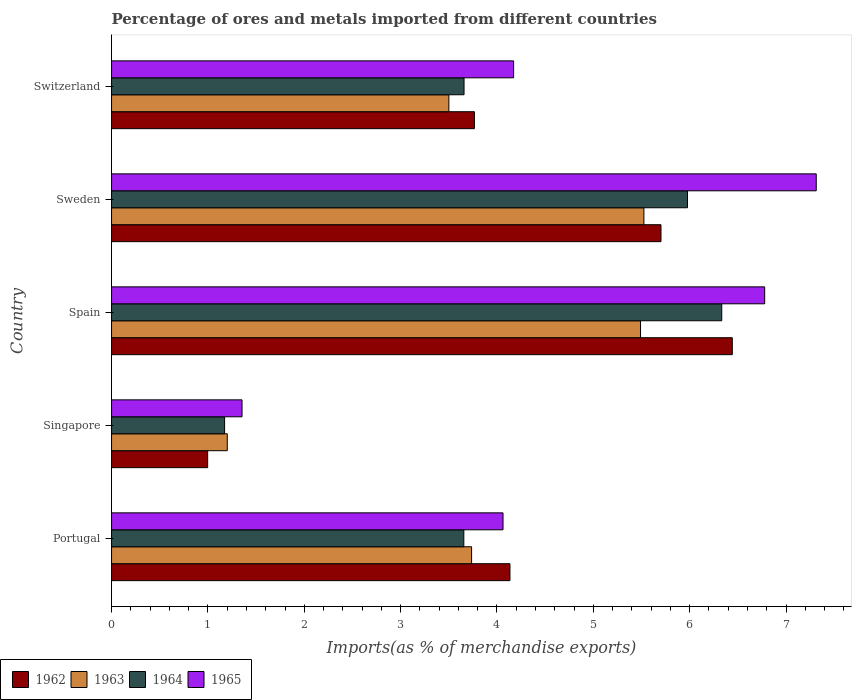How many different coloured bars are there?
Offer a very short reply. 4. How many groups of bars are there?
Your answer should be very brief. 5. How many bars are there on the 1st tick from the bottom?
Provide a short and direct response. 4. What is the label of the 1st group of bars from the top?
Keep it short and to the point. Switzerland. What is the percentage of imports to different countries in 1962 in Portugal?
Your answer should be very brief. 4.13. Across all countries, what is the maximum percentage of imports to different countries in 1965?
Your answer should be very brief. 7.31. Across all countries, what is the minimum percentage of imports to different countries in 1963?
Provide a succinct answer. 1.2. In which country was the percentage of imports to different countries in 1965 maximum?
Provide a succinct answer. Sweden. In which country was the percentage of imports to different countries in 1962 minimum?
Provide a succinct answer. Singapore. What is the total percentage of imports to different countries in 1965 in the graph?
Offer a very short reply. 23.68. What is the difference between the percentage of imports to different countries in 1963 in Portugal and that in Spain?
Give a very brief answer. -1.75. What is the difference between the percentage of imports to different countries in 1965 in Sweden and the percentage of imports to different countries in 1963 in Spain?
Give a very brief answer. 1.82. What is the average percentage of imports to different countries in 1963 per country?
Your response must be concise. 3.89. What is the difference between the percentage of imports to different countries in 1965 and percentage of imports to different countries in 1964 in Sweden?
Provide a short and direct response. 1.34. In how many countries, is the percentage of imports to different countries in 1962 greater than 6.8 %?
Your answer should be very brief. 0. What is the ratio of the percentage of imports to different countries in 1963 in Spain to that in Switzerland?
Give a very brief answer. 1.57. Is the difference between the percentage of imports to different countries in 1965 in Portugal and Switzerland greater than the difference between the percentage of imports to different countries in 1964 in Portugal and Switzerland?
Your response must be concise. No. What is the difference between the highest and the second highest percentage of imports to different countries in 1964?
Your answer should be compact. 0.36. What is the difference between the highest and the lowest percentage of imports to different countries in 1962?
Your answer should be very brief. 5.45. What does the 2nd bar from the top in Switzerland represents?
Your answer should be compact. 1964. What does the 2nd bar from the bottom in Portugal represents?
Provide a succinct answer. 1963. Are all the bars in the graph horizontal?
Your answer should be very brief. Yes. Does the graph contain grids?
Ensure brevity in your answer.  No. How many legend labels are there?
Provide a succinct answer. 4. What is the title of the graph?
Your answer should be compact. Percentage of ores and metals imported from different countries. Does "1981" appear as one of the legend labels in the graph?
Offer a very short reply. No. What is the label or title of the X-axis?
Ensure brevity in your answer.  Imports(as % of merchandise exports). What is the label or title of the Y-axis?
Keep it short and to the point. Country. What is the Imports(as % of merchandise exports) in 1962 in Portugal?
Provide a succinct answer. 4.13. What is the Imports(as % of merchandise exports) of 1963 in Portugal?
Offer a very short reply. 3.74. What is the Imports(as % of merchandise exports) of 1964 in Portugal?
Offer a terse response. 3.66. What is the Imports(as % of merchandise exports) in 1965 in Portugal?
Your response must be concise. 4.06. What is the Imports(as % of merchandise exports) in 1962 in Singapore?
Offer a very short reply. 1. What is the Imports(as % of merchandise exports) in 1963 in Singapore?
Keep it short and to the point. 1.2. What is the Imports(as % of merchandise exports) in 1964 in Singapore?
Your answer should be compact. 1.17. What is the Imports(as % of merchandise exports) of 1965 in Singapore?
Provide a succinct answer. 1.35. What is the Imports(as % of merchandise exports) of 1962 in Spain?
Give a very brief answer. 6.44. What is the Imports(as % of merchandise exports) of 1963 in Spain?
Make the answer very short. 5.49. What is the Imports(as % of merchandise exports) in 1964 in Spain?
Make the answer very short. 6.33. What is the Imports(as % of merchandise exports) in 1965 in Spain?
Offer a very short reply. 6.78. What is the Imports(as % of merchandise exports) in 1962 in Sweden?
Your response must be concise. 5.7. What is the Imports(as % of merchandise exports) in 1963 in Sweden?
Provide a succinct answer. 5.52. What is the Imports(as % of merchandise exports) of 1964 in Sweden?
Provide a succinct answer. 5.98. What is the Imports(as % of merchandise exports) of 1965 in Sweden?
Your answer should be compact. 7.31. What is the Imports(as % of merchandise exports) in 1962 in Switzerland?
Offer a terse response. 3.77. What is the Imports(as % of merchandise exports) in 1963 in Switzerland?
Provide a short and direct response. 3.5. What is the Imports(as % of merchandise exports) in 1964 in Switzerland?
Give a very brief answer. 3.66. What is the Imports(as % of merchandise exports) in 1965 in Switzerland?
Your answer should be compact. 4.17. Across all countries, what is the maximum Imports(as % of merchandise exports) of 1962?
Keep it short and to the point. 6.44. Across all countries, what is the maximum Imports(as % of merchandise exports) of 1963?
Ensure brevity in your answer.  5.52. Across all countries, what is the maximum Imports(as % of merchandise exports) of 1964?
Your response must be concise. 6.33. Across all countries, what is the maximum Imports(as % of merchandise exports) in 1965?
Provide a short and direct response. 7.31. Across all countries, what is the minimum Imports(as % of merchandise exports) in 1962?
Your answer should be compact. 1. Across all countries, what is the minimum Imports(as % of merchandise exports) in 1963?
Offer a terse response. 1.2. Across all countries, what is the minimum Imports(as % of merchandise exports) in 1964?
Your response must be concise. 1.17. Across all countries, what is the minimum Imports(as % of merchandise exports) of 1965?
Offer a very short reply. 1.35. What is the total Imports(as % of merchandise exports) in 1962 in the graph?
Make the answer very short. 21.04. What is the total Imports(as % of merchandise exports) in 1963 in the graph?
Offer a terse response. 19.45. What is the total Imports(as % of merchandise exports) in 1964 in the graph?
Provide a succinct answer. 20.8. What is the total Imports(as % of merchandise exports) of 1965 in the graph?
Make the answer very short. 23.68. What is the difference between the Imports(as % of merchandise exports) in 1962 in Portugal and that in Singapore?
Your answer should be very brief. 3.14. What is the difference between the Imports(as % of merchandise exports) in 1963 in Portugal and that in Singapore?
Give a very brief answer. 2.54. What is the difference between the Imports(as % of merchandise exports) in 1964 in Portugal and that in Singapore?
Your answer should be very brief. 2.48. What is the difference between the Imports(as % of merchandise exports) in 1965 in Portugal and that in Singapore?
Your answer should be compact. 2.71. What is the difference between the Imports(as % of merchandise exports) in 1962 in Portugal and that in Spain?
Provide a short and direct response. -2.31. What is the difference between the Imports(as % of merchandise exports) of 1963 in Portugal and that in Spain?
Offer a very short reply. -1.75. What is the difference between the Imports(as % of merchandise exports) in 1964 in Portugal and that in Spain?
Keep it short and to the point. -2.68. What is the difference between the Imports(as % of merchandise exports) of 1965 in Portugal and that in Spain?
Make the answer very short. -2.72. What is the difference between the Imports(as % of merchandise exports) in 1962 in Portugal and that in Sweden?
Your answer should be compact. -1.57. What is the difference between the Imports(as % of merchandise exports) in 1963 in Portugal and that in Sweden?
Keep it short and to the point. -1.79. What is the difference between the Imports(as % of merchandise exports) of 1964 in Portugal and that in Sweden?
Your answer should be very brief. -2.32. What is the difference between the Imports(as % of merchandise exports) of 1965 in Portugal and that in Sweden?
Offer a very short reply. -3.25. What is the difference between the Imports(as % of merchandise exports) in 1962 in Portugal and that in Switzerland?
Provide a short and direct response. 0.37. What is the difference between the Imports(as % of merchandise exports) of 1963 in Portugal and that in Switzerland?
Offer a very short reply. 0.24. What is the difference between the Imports(as % of merchandise exports) in 1964 in Portugal and that in Switzerland?
Provide a short and direct response. -0. What is the difference between the Imports(as % of merchandise exports) in 1965 in Portugal and that in Switzerland?
Your response must be concise. -0.11. What is the difference between the Imports(as % of merchandise exports) of 1962 in Singapore and that in Spain?
Give a very brief answer. -5.45. What is the difference between the Imports(as % of merchandise exports) of 1963 in Singapore and that in Spain?
Provide a succinct answer. -4.29. What is the difference between the Imports(as % of merchandise exports) in 1964 in Singapore and that in Spain?
Offer a very short reply. -5.16. What is the difference between the Imports(as % of merchandise exports) in 1965 in Singapore and that in Spain?
Ensure brevity in your answer.  -5.42. What is the difference between the Imports(as % of merchandise exports) of 1962 in Singapore and that in Sweden?
Your answer should be very brief. -4.7. What is the difference between the Imports(as % of merchandise exports) of 1963 in Singapore and that in Sweden?
Your response must be concise. -4.32. What is the difference between the Imports(as % of merchandise exports) in 1964 in Singapore and that in Sweden?
Provide a succinct answer. -4.8. What is the difference between the Imports(as % of merchandise exports) of 1965 in Singapore and that in Sweden?
Offer a terse response. -5.96. What is the difference between the Imports(as % of merchandise exports) of 1962 in Singapore and that in Switzerland?
Make the answer very short. -2.77. What is the difference between the Imports(as % of merchandise exports) of 1963 in Singapore and that in Switzerland?
Your answer should be very brief. -2.3. What is the difference between the Imports(as % of merchandise exports) in 1964 in Singapore and that in Switzerland?
Keep it short and to the point. -2.49. What is the difference between the Imports(as % of merchandise exports) in 1965 in Singapore and that in Switzerland?
Keep it short and to the point. -2.82. What is the difference between the Imports(as % of merchandise exports) of 1962 in Spain and that in Sweden?
Give a very brief answer. 0.74. What is the difference between the Imports(as % of merchandise exports) in 1963 in Spain and that in Sweden?
Offer a terse response. -0.04. What is the difference between the Imports(as % of merchandise exports) in 1964 in Spain and that in Sweden?
Give a very brief answer. 0.36. What is the difference between the Imports(as % of merchandise exports) of 1965 in Spain and that in Sweden?
Your answer should be compact. -0.54. What is the difference between the Imports(as % of merchandise exports) of 1962 in Spain and that in Switzerland?
Provide a succinct answer. 2.68. What is the difference between the Imports(as % of merchandise exports) in 1963 in Spain and that in Switzerland?
Provide a short and direct response. 1.99. What is the difference between the Imports(as % of merchandise exports) of 1964 in Spain and that in Switzerland?
Provide a short and direct response. 2.67. What is the difference between the Imports(as % of merchandise exports) of 1965 in Spain and that in Switzerland?
Provide a short and direct response. 2.61. What is the difference between the Imports(as % of merchandise exports) of 1962 in Sweden and that in Switzerland?
Offer a terse response. 1.94. What is the difference between the Imports(as % of merchandise exports) of 1963 in Sweden and that in Switzerland?
Offer a terse response. 2.02. What is the difference between the Imports(as % of merchandise exports) of 1964 in Sweden and that in Switzerland?
Offer a terse response. 2.32. What is the difference between the Imports(as % of merchandise exports) in 1965 in Sweden and that in Switzerland?
Ensure brevity in your answer.  3.14. What is the difference between the Imports(as % of merchandise exports) in 1962 in Portugal and the Imports(as % of merchandise exports) in 1963 in Singapore?
Make the answer very short. 2.93. What is the difference between the Imports(as % of merchandise exports) of 1962 in Portugal and the Imports(as % of merchandise exports) of 1964 in Singapore?
Your answer should be compact. 2.96. What is the difference between the Imports(as % of merchandise exports) of 1962 in Portugal and the Imports(as % of merchandise exports) of 1965 in Singapore?
Your response must be concise. 2.78. What is the difference between the Imports(as % of merchandise exports) in 1963 in Portugal and the Imports(as % of merchandise exports) in 1964 in Singapore?
Provide a short and direct response. 2.56. What is the difference between the Imports(as % of merchandise exports) in 1963 in Portugal and the Imports(as % of merchandise exports) in 1965 in Singapore?
Offer a very short reply. 2.38. What is the difference between the Imports(as % of merchandise exports) in 1964 in Portugal and the Imports(as % of merchandise exports) in 1965 in Singapore?
Keep it short and to the point. 2.3. What is the difference between the Imports(as % of merchandise exports) in 1962 in Portugal and the Imports(as % of merchandise exports) in 1963 in Spain?
Provide a succinct answer. -1.36. What is the difference between the Imports(as % of merchandise exports) in 1962 in Portugal and the Imports(as % of merchandise exports) in 1964 in Spain?
Offer a terse response. -2.2. What is the difference between the Imports(as % of merchandise exports) of 1962 in Portugal and the Imports(as % of merchandise exports) of 1965 in Spain?
Your response must be concise. -2.64. What is the difference between the Imports(as % of merchandise exports) in 1963 in Portugal and the Imports(as % of merchandise exports) in 1964 in Spain?
Your answer should be compact. -2.6. What is the difference between the Imports(as % of merchandise exports) in 1963 in Portugal and the Imports(as % of merchandise exports) in 1965 in Spain?
Ensure brevity in your answer.  -3.04. What is the difference between the Imports(as % of merchandise exports) of 1964 in Portugal and the Imports(as % of merchandise exports) of 1965 in Spain?
Provide a short and direct response. -3.12. What is the difference between the Imports(as % of merchandise exports) of 1962 in Portugal and the Imports(as % of merchandise exports) of 1963 in Sweden?
Your answer should be very brief. -1.39. What is the difference between the Imports(as % of merchandise exports) in 1962 in Portugal and the Imports(as % of merchandise exports) in 1964 in Sweden?
Your answer should be very brief. -1.84. What is the difference between the Imports(as % of merchandise exports) of 1962 in Portugal and the Imports(as % of merchandise exports) of 1965 in Sweden?
Ensure brevity in your answer.  -3.18. What is the difference between the Imports(as % of merchandise exports) in 1963 in Portugal and the Imports(as % of merchandise exports) in 1964 in Sweden?
Your answer should be compact. -2.24. What is the difference between the Imports(as % of merchandise exports) of 1963 in Portugal and the Imports(as % of merchandise exports) of 1965 in Sweden?
Your answer should be very brief. -3.58. What is the difference between the Imports(as % of merchandise exports) of 1964 in Portugal and the Imports(as % of merchandise exports) of 1965 in Sweden?
Your answer should be compact. -3.66. What is the difference between the Imports(as % of merchandise exports) of 1962 in Portugal and the Imports(as % of merchandise exports) of 1963 in Switzerland?
Your response must be concise. 0.63. What is the difference between the Imports(as % of merchandise exports) in 1962 in Portugal and the Imports(as % of merchandise exports) in 1964 in Switzerland?
Provide a short and direct response. 0.48. What is the difference between the Imports(as % of merchandise exports) of 1962 in Portugal and the Imports(as % of merchandise exports) of 1965 in Switzerland?
Make the answer very short. -0.04. What is the difference between the Imports(as % of merchandise exports) in 1963 in Portugal and the Imports(as % of merchandise exports) in 1964 in Switzerland?
Your answer should be compact. 0.08. What is the difference between the Imports(as % of merchandise exports) in 1963 in Portugal and the Imports(as % of merchandise exports) in 1965 in Switzerland?
Keep it short and to the point. -0.44. What is the difference between the Imports(as % of merchandise exports) in 1964 in Portugal and the Imports(as % of merchandise exports) in 1965 in Switzerland?
Provide a short and direct response. -0.52. What is the difference between the Imports(as % of merchandise exports) of 1962 in Singapore and the Imports(as % of merchandise exports) of 1963 in Spain?
Your answer should be very brief. -4.49. What is the difference between the Imports(as % of merchandise exports) of 1962 in Singapore and the Imports(as % of merchandise exports) of 1964 in Spain?
Provide a succinct answer. -5.34. What is the difference between the Imports(as % of merchandise exports) of 1962 in Singapore and the Imports(as % of merchandise exports) of 1965 in Spain?
Your answer should be very brief. -5.78. What is the difference between the Imports(as % of merchandise exports) of 1963 in Singapore and the Imports(as % of merchandise exports) of 1964 in Spain?
Keep it short and to the point. -5.13. What is the difference between the Imports(as % of merchandise exports) of 1963 in Singapore and the Imports(as % of merchandise exports) of 1965 in Spain?
Make the answer very short. -5.58. What is the difference between the Imports(as % of merchandise exports) in 1964 in Singapore and the Imports(as % of merchandise exports) in 1965 in Spain?
Provide a short and direct response. -5.61. What is the difference between the Imports(as % of merchandise exports) in 1962 in Singapore and the Imports(as % of merchandise exports) in 1963 in Sweden?
Offer a very short reply. -4.53. What is the difference between the Imports(as % of merchandise exports) in 1962 in Singapore and the Imports(as % of merchandise exports) in 1964 in Sweden?
Give a very brief answer. -4.98. What is the difference between the Imports(as % of merchandise exports) in 1962 in Singapore and the Imports(as % of merchandise exports) in 1965 in Sweden?
Your answer should be compact. -6.32. What is the difference between the Imports(as % of merchandise exports) in 1963 in Singapore and the Imports(as % of merchandise exports) in 1964 in Sweden?
Provide a succinct answer. -4.78. What is the difference between the Imports(as % of merchandise exports) in 1963 in Singapore and the Imports(as % of merchandise exports) in 1965 in Sweden?
Make the answer very short. -6.11. What is the difference between the Imports(as % of merchandise exports) in 1964 in Singapore and the Imports(as % of merchandise exports) in 1965 in Sweden?
Ensure brevity in your answer.  -6.14. What is the difference between the Imports(as % of merchandise exports) in 1962 in Singapore and the Imports(as % of merchandise exports) in 1963 in Switzerland?
Give a very brief answer. -2.5. What is the difference between the Imports(as % of merchandise exports) of 1962 in Singapore and the Imports(as % of merchandise exports) of 1964 in Switzerland?
Keep it short and to the point. -2.66. What is the difference between the Imports(as % of merchandise exports) in 1962 in Singapore and the Imports(as % of merchandise exports) in 1965 in Switzerland?
Offer a very short reply. -3.18. What is the difference between the Imports(as % of merchandise exports) of 1963 in Singapore and the Imports(as % of merchandise exports) of 1964 in Switzerland?
Ensure brevity in your answer.  -2.46. What is the difference between the Imports(as % of merchandise exports) in 1963 in Singapore and the Imports(as % of merchandise exports) in 1965 in Switzerland?
Provide a short and direct response. -2.97. What is the difference between the Imports(as % of merchandise exports) of 1964 in Singapore and the Imports(as % of merchandise exports) of 1965 in Switzerland?
Keep it short and to the point. -3. What is the difference between the Imports(as % of merchandise exports) in 1962 in Spain and the Imports(as % of merchandise exports) in 1963 in Sweden?
Keep it short and to the point. 0.92. What is the difference between the Imports(as % of merchandise exports) of 1962 in Spain and the Imports(as % of merchandise exports) of 1964 in Sweden?
Keep it short and to the point. 0.47. What is the difference between the Imports(as % of merchandise exports) in 1962 in Spain and the Imports(as % of merchandise exports) in 1965 in Sweden?
Ensure brevity in your answer.  -0.87. What is the difference between the Imports(as % of merchandise exports) in 1963 in Spain and the Imports(as % of merchandise exports) in 1964 in Sweden?
Give a very brief answer. -0.49. What is the difference between the Imports(as % of merchandise exports) of 1963 in Spain and the Imports(as % of merchandise exports) of 1965 in Sweden?
Ensure brevity in your answer.  -1.82. What is the difference between the Imports(as % of merchandise exports) in 1964 in Spain and the Imports(as % of merchandise exports) in 1965 in Sweden?
Ensure brevity in your answer.  -0.98. What is the difference between the Imports(as % of merchandise exports) in 1962 in Spain and the Imports(as % of merchandise exports) in 1963 in Switzerland?
Your answer should be very brief. 2.94. What is the difference between the Imports(as % of merchandise exports) of 1962 in Spain and the Imports(as % of merchandise exports) of 1964 in Switzerland?
Your response must be concise. 2.78. What is the difference between the Imports(as % of merchandise exports) in 1962 in Spain and the Imports(as % of merchandise exports) in 1965 in Switzerland?
Your answer should be compact. 2.27. What is the difference between the Imports(as % of merchandise exports) in 1963 in Spain and the Imports(as % of merchandise exports) in 1964 in Switzerland?
Keep it short and to the point. 1.83. What is the difference between the Imports(as % of merchandise exports) of 1963 in Spain and the Imports(as % of merchandise exports) of 1965 in Switzerland?
Give a very brief answer. 1.32. What is the difference between the Imports(as % of merchandise exports) of 1964 in Spain and the Imports(as % of merchandise exports) of 1965 in Switzerland?
Your answer should be very brief. 2.16. What is the difference between the Imports(as % of merchandise exports) of 1962 in Sweden and the Imports(as % of merchandise exports) of 1963 in Switzerland?
Give a very brief answer. 2.2. What is the difference between the Imports(as % of merchandise exports) in 1962 in Sweden and the Imports(as % of merchandise exports) in 1964 in Switzerland?
Give a very brief answer. 2.04. What is the difference between the Imports(as % of merchandise exports) in 1962 in Sweden and the Imports(as % of merchandise exports) in 1965 in Switzerland?
Your answer should be compact. 1.53. What is the difference between the Imports(as % of merchandise exports) of 1963 in Sweden and the Imports(as % of merchandise exports) of 1964 in Switzerland?
Offer a very short reply. 1.87. What is the difference between the Imports(as % of merchandise exports) in 1963 in Sweden and the Imports(as % of merchandise exports) in 1965 in Switzerland?
Provide a short and direct response. 1.35. What is the difference between the Imports(as % of merchandise exports) in 1964 in Sweden and the Imports(as % of merchandise exports) in 1965 in Switzerland?
Offer a very short reply. 1.8. What is the average Imports(as % of merchandise exports) of 1962 per country?
Keep it short and to the point. 4.21. What is the average Imports(as % of merchandise exports) of 1963 per country?
Keep it short and to the point. 3.89. What is the average Imports(as % of merchandise exports) of 1964 per country?
Keep it short and to the point. 4.16. What is the average Imports(as % of merchandise exports) in 1965 per country?
Your response must be concise. 4.74. What is the difference between the Imports(as % of merchandise exports) of 1962 and Imports(as % of merchandise exports) of 1963 in Portugal?
Keep it short and to the point. 0.4. What is the difference between the Imports(as % of merchandise exports) in 1962 and Imports(as % of merchandise exports) in 1964 in Portugal?
Make the answer very short. 0.48. What is the difference between the Imports(as % of merchandise exports) in 1962 and Imports(as % of merchandise exports) in 1965 in Portugal?
Your answer should be compact. 0.07. What is the difference between the Imports(as % of merchandise exports) in 1963 and Imports(as % of merchandise exports) in 1964 in Portugal?
Provide a succinct answer. 0.08. What is the difference between the Imports(as % of merchandise exports) in 1963 and Imports(as % of merchandise exports) in 1965 in Portugal?
Offer a very short reply. -0.33. What is the difference between the Imports(as % of merchandise exports) of 1964 and Imports(as % of merchandise exports) of 1965 in Portugal?
Make the answer very short. -0.41. What is the difference between the Imports(as % of merchandise exports) of 1962 and Imports(as % of merchandise exports) of 1963 in Singapore?
Give a very brief answer. -0.2. What is the difference between the Imports(as % of merchandise exports) in 1962 and Imports(as % of merchandise exports) in 1964 in Singapore?
Keep it short and to the point. -0.18. What is the difference between the Imports(as % of merchandise exports) in 1962 and Imports(as % of merchandise exports) in 1965 in Singapore?
Your answer should be compact. -0.36. What is the difference between the Imports(as % of merchandise exports) of 1963 and Imports(as % of merchandise exports) of 1964 in Singapore?
Your answer should be compact. 0.03. What is the difference between the Imports(as % of merchandise exports) of 1963 and Imports(as % of merchandise exports) of 1965 in Singapore?
Offer a terse response. -0.15. What is the difference between the Imports(as % of merchandise exports) in 1964 and Imports(as % of merchandise exports) in 1965 in Singapore?
Keep it short and to the point. -0.18. What is the difference between the Imports(as % of merchandise exports) of 1962 and Imports(as % of merchandise exports) of 1964 in Spain?
Your answer should be very brief. 0.11. What is the difference between the Imports(as % of merchandise exports) in 1962 and Imports(as % of merchandise exports) in 1965 in Spain?
Provide a succinct answer. -0.34. What is the difference between the Imports(as % of merchandise exports) of 1963 and Imports(as % of merchandise exports) of 1964 in Spain?
Your response must be concise. -0.84. What is the difference between the Imports(as % of merchandise exports) of 1963 and Imports(as % of merchandise exports) of 1965 in Spain?
Provide a short and direct response. -1.29. What is the difference between the Imports(as % of merchandise exports) of 1964 and Imports(as % of merchandise exports) of 1965 in Spain?
Your answer should be compact. -0.45. What is the difference between the Imports(as % of merchandise exports) in 1962 and Imports(as % of merchandise exports) in 1963 in Sweden?
Keep it short and to the point. 0.18. What is the difference between the Imports(as % of merchandise exports) of 1962 and Imports(as % of merchandise exports) of 1964 in Sweden?
Ensure brevity in your answer.  -0.28. What is the difference between the Imports(as % of merchandise exports) of 1962 and Imports(as % of merchandise exports) of 1965 in Sweden?
Offer a very short reply. -1.61. What is the difference between the Imports(as % of merchandise exports) of 1963 and Imports(as % of merchandise exports) of 1964 in Sweden?
Offer a very short reply. -0.45. What is the difference between the Imports(as % of merchandise exports) of 1963 and Imports(as % of merchandise exports) of 1965 in Sweden?
Your answer should be very brief. -1.79. What is the difference between the Imports(as % of merchandise exports) of 1964 and Imports(as % of merchandise exports) of 1965 in Sweden?
Your response must be concise. -1.34. What is the difference between the Imports(as % of merchandise exports) in 1962 and Imports(as % of merchandise exports) in 1963 in Switzerland?
Make the answer very short. 0.27. What is the difference between the Imports(as % of merchandise exports) of 1962 and Imports(as % of merchandise exports) of 1964 in Switzerland?
Keep it short and to the point. 0.11. What is the difference between the Imports(as % of merchandise exports) in 1962 and Imports(as % of merchandise exports) in 1965 in Switzerland?
Your answer should be very brief. -0.41. What is the difference between the Imports(as % of merchandise exports) of 1963 and Imports(as % of merchandise exports) of 1964 in Switzerland?
Provide a succinct answer. -0.16. What is the difference between the Imports(as % of merchandise exports) of 1963 and Imports(as % of merchandise exports) of 1965 in Switzerland?
Offer a very short reply. -0.67. What is the difference between the Imports(as % of merchandise exports) in 1964 and Imports(as % of merchandise exports) in 1965 in Switzerland?
Provide a succinct answer. -0.51. What is the ratio of the Imports(as % of merchandise exports) of 1962 in Portugal to that in Singapore?
Keep it short and to the point. 4.15. What is the ratio of the Imports(as % of merchandise exports) of 1963 in Portugal to that in Singapore?
Ensure brevity in your answer.  3.11. What is the ratio of the Imports(as % of merchandise exports) in 1964 in Portugal to that in Singapore?
Offer a terse response. 3.12. What is the ratio of the Imports(as % of merchandise exports) in 1965 in Portugal to that in Singapore?
Provide a succinct answer. 3. What is the ratio of the Imports(as % of merchandise exports) of 1962 in Portugal to that in Spain?
Give a very brief answer. 0.64. What is the ratio of the Imports(as % of merchandise exports) of 1963 in Portugal to that in Spain?
Provide a succinct answer. 0.68. What is the ratio of the Imports(as % of merchandise exports) of 1964 in Portugal to that in Spain?
Make the answer very short. 0.58. What is the ratio of the Imports(as % of merchandise exports) of 1965 in Portugal to that in Spain?
Your response must be concise. 0.6. What is the ratio of the Imports(as % of merchandise exports) in 1962 in Portugal to that in Sweden?
Provide a succinct answer. 0.73. What is the ratio of the Imports(as % of merchandise exports) in 1963 in Portugal to that in Sweden?
Your answer should be compact. 0.68. What is the ratio of the Imports(as % of merchandise exports) of 1964 in Portugal to that in Sweden?
Offer a very short reply. 0.61. What is the ratio of the Imports(as % of merchandise exports) of 1965 in Portugal to that in Sweden?
Provide a succinct answer. 0.56. What is the ratio of the Imports(as % of merchandise exports) of 1962 in Portugal to that in Switzerland?
Offer a terse response. 1.1. What is the ratio of the Imports(as % of merchandise exports) in 1963 in Portugal to that in Switzerland?
Your response must be concise. 1.07. What is the ratio of the Imports(as % of merchandise exports) of 1965 in Portugal to that in Switzerland?
Provide a short and direct response. 0.97. What is the ratio of the Imports(as % of merchandise exports) in 1962 in Singapore to that in Spain?
Your answer should be compact. 0.15. What is the ratio of the Imports(as % of merchandise exports) of 1963 in Singapore to that in Spain?
Your answer should be very brief. 0.22. What is the ratio of the Imports(as % of merchandise exports) in 1964 in Singapore to that in Spain?
Your answer should be very brief. 0.19. What is the ratio of the Imports(as % of merchandise exports) in 1965 in Singapore to that in Spain?
Offer a very short reply. 0.2. What is the ratio of the Imports(as % of merchandise exports) of 1962 in Singapore to that in Sweden?
Offer a very short reply. 0.17. What is the ratio of the Imports(as % of merchandise exports) of 1963 in Singapore to that in Sweden?
Offer a terse response. 0.22. What is the ratio of the Imports(as % of merchandise exports) of 1964 in Singapore to that in Sweden?
Ensure brevity in your answer.  0.2. What is the ratio of the Imports(as % of merchandise exports) of 1965 in Singapore to that in Sweden?
Your response must be concise. 0.19. What is the ratio of the Imports(as % of merchandise exports) of 1962 in Singapore to that in Switzerland?
Your response must be concise. 0.26. What is the ratio of the Imports(as % of merchandise exports) in 1963 in Singapore to that in Switzerland?
Offer a very short reply. 0.34. What is the ratio of the Imports(as % of merchandise exports) in 1964 in Singapore to that in Switzerland?
Ensure brevity in your answer.  0.32. What is the ratio of the Imports(as % of merchandise exports) in 1965 in Singapore to that in Switzerland?
Your answer should be compact. 0.32. What is the ratio of the Imports(as % of merchandise exports) in 1962 in Spain to that in Sweden?
Make the answer very short. 1.13. What is the ratio of the Imports(as % of merchandise exports) in 1964 in Spain to that in Sweden?
Give a very brief answer. 1.06. What is the ratio of the Imports(as % of merchandise exports) in 1965 in Spain to that in Sweden?
Your answer should be very brief. 0.93. What is the ratio of the Imports(as % of merchandise exports) of 1962 in Spain to that in Switzerland?
Keep it short and to the point. 1.71. What is the ratio of the Imports(as % of merchandise exports) in 1963 in Spain to that in Switzerland?
Ensure brevity in your answer.  1.57. What is the ratio of the Imports(as % of merchandise exports) of 1964 in Spain to that in Switzerland?
Ensure brevity in your answer.  1.73. What is the ratio of the Imports(as % of merchandise exports) of 1965 in Spain to that in Switzerland?
Make the answer very short. 1.62. What is the ratio of the Imports(as % of merchandise exports) in 1962 in Sweden to that in Switzerland?
Provide a short and direct response. 1.51. What is the ratio of the Imports(as % of merchandise exports) in 1963 in Sweden to that in Switzerland?
Provide a short and direct response. 1.58. What is the ratio of the Imports(as % of merchandise exports) in 1964 in Sweden to that in Switzerland?
Make the answer very short. 1.63. What is the ratio of the Imports(as % of merchandise exports) in 1965 in Sweden to that in Switzerland?
Make the answer very short. 1.75. What is the difference between the highest and the second highest Imports(as % of merchandise exports) in 1962?
Provide a short and direct response. 0.74. What is the difference between the highest and the second highest Imports(as % of merchandise exports) in 1963?
Your response must be concise. 0.04. What is the difference between the highest and the second highest Imports(as % of merchandise exports) in 1964?
Make the answer very short. 0.36. What is the difference between the highest and the second highest Imports(as % of merchandise exports) of 1965?
Provide a short and direct response. 0.54. What is the difference between the highest and the lowest Imports(as % of merchandise exports) of 1962?
Ensure brevity in your answer.  5.45. What is the difference between the highest and the lowest Imports(as % of merchandise exports) in 1963?
Provide a succinct answer. 4.32. What is the difference between the highest and the lowest Imports(as % of merchandise exports) in 1964?
Offer a terse response. 5.16. What is the difference between the highest and the lowest Imports(as % of merchandise exports) in 1965?
Offer a terse response. 5.96. 